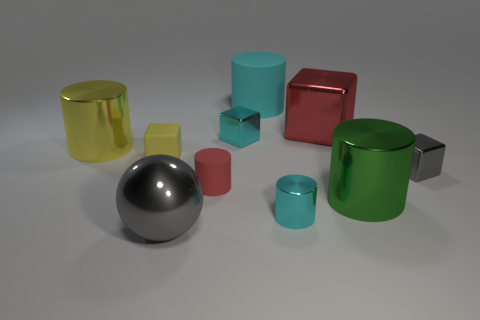Add 2 gray balls. How many gray balls are left? 3 Add 5 cyan cubes. How many cyan cubes exist? 6 Subtract all green cylinders. How many cylinders are left? 4 Subtract all green metallic cylinders. How many cylinders are left? 4 Subtract 0 blue balls. How many objects are left? 10 Subtract all spheres. How many objects are left? 9 Subtract 1 balls. How many balls are left? 0 Subtract all purple balls. Subtract all yellow blocks. How many balls are left? 1 Subtract all green spheres. How many yellow cylinders are left? 1 Subtract all red objects. Subtract all yellow cylinders. How many objects are left? 7 